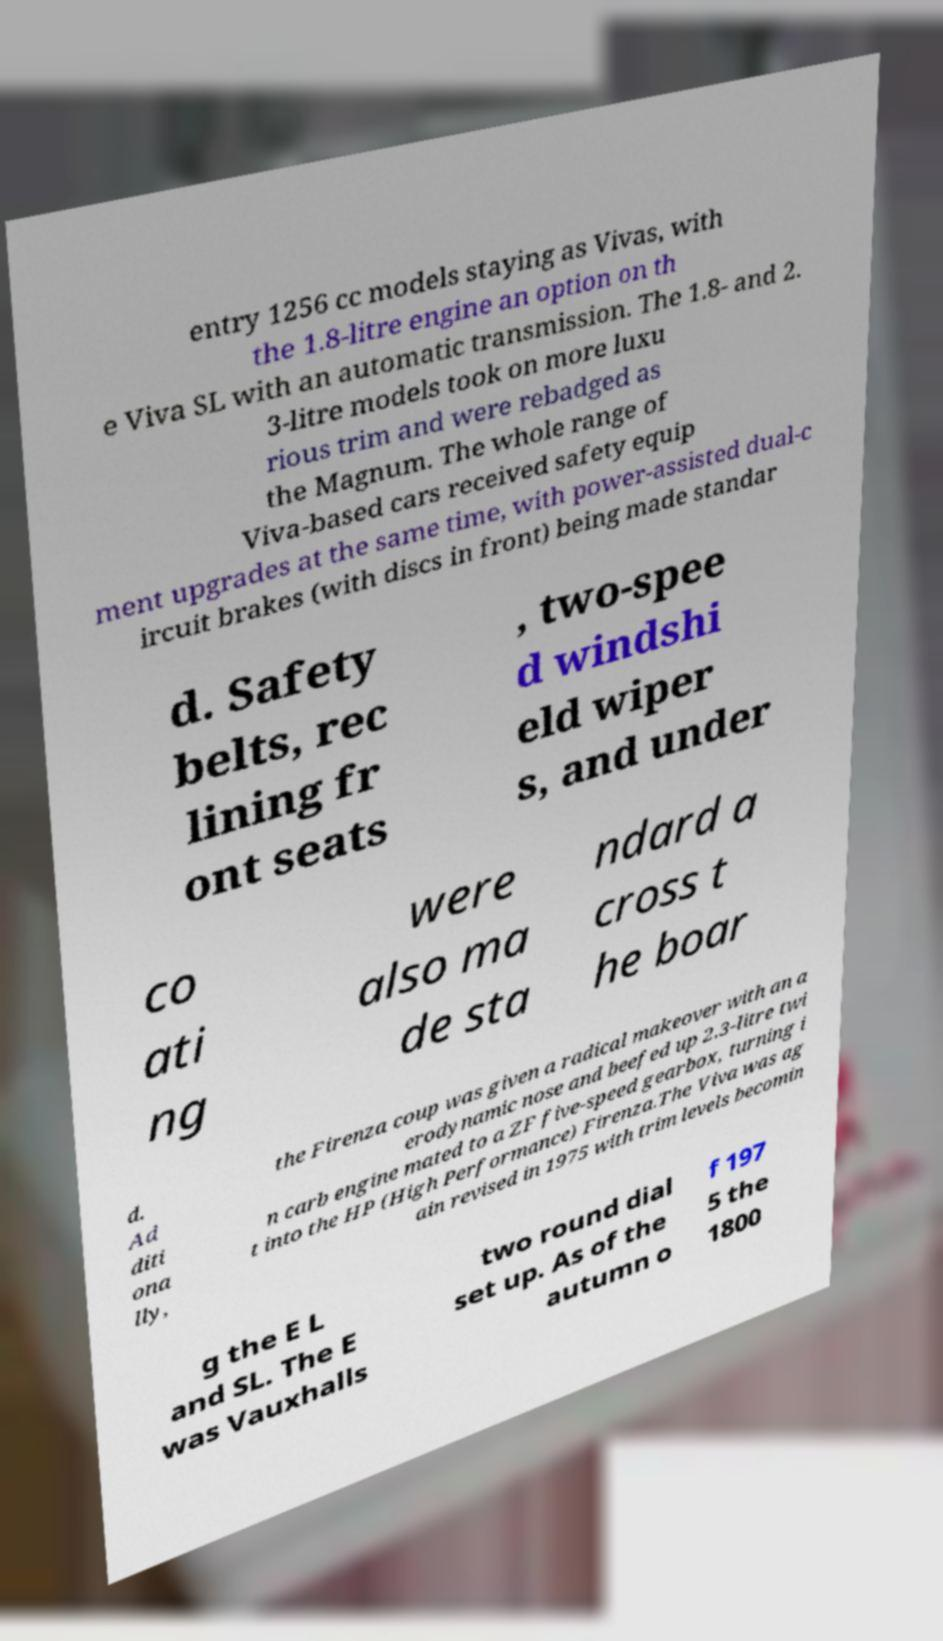Please read and relay the text visible in this image. What does it say? entry 1256 cc models staying as Vivas, with the 1.8-litre engine an option on th e Viva SL with an automatic transmission. The 1.8- and 2. 3-litre models took on more luxu rious trim and were rebadged as the Magnum. The whole range of Viva-based cars received safety equip ment upgrades at the same time, with power-assisted dual-c ircuit brakes (with discs in front) being made standar d. Safety belts, rec lining fr ont seats , two-spee d windshi eld wiper s, and under co ati ng were also ma de sta ndard a cross t he boar d. Ad diti ona lly, the Firenza coup was given a radical makeover with an a erodynamic nose and beefed up 2.3-litre twi n carb engine mated to a ZF five-speed gearbox, turning i t into the HP (High Performance) Firenza.The Viva was ag ain revised in 1975 with trim levels becomin g the E L and SL. The E was Vauxhalls two round dial set up. As of the autumn o f 197 5 the 1800 